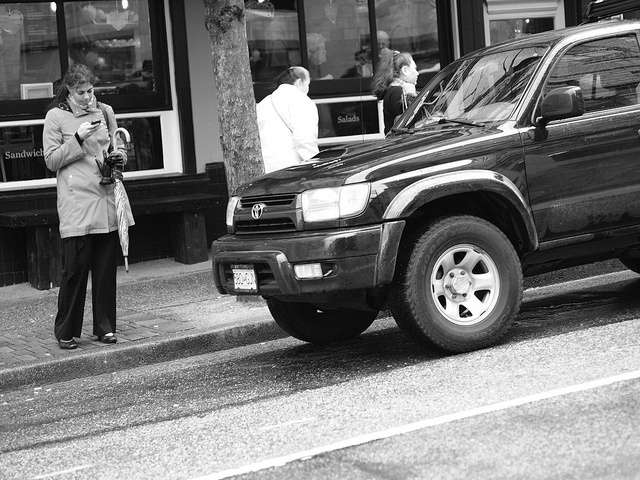Describe the objects in this image and their specific colors. I can see truck in black, gray, lightgray, and darkgray tones, car in black, gray, lightgray, and darkgray tones, people in black, darkgray, lightgray, and gray tones, people in black, white, gray, and darkgray tones, and people in black, gray, lightgray, and darkgray tones in this image. 